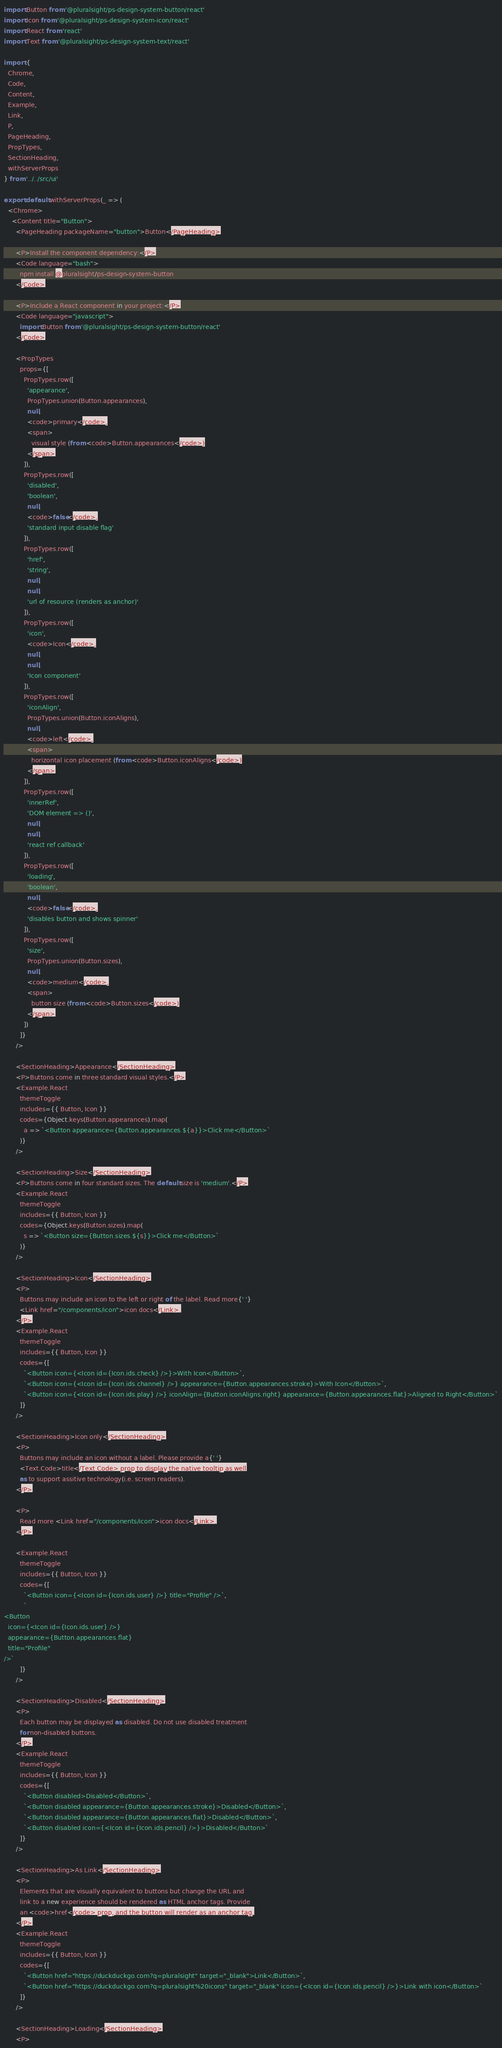<code> <loc_0><loc_0><loc_500><loc_500><_JavaScript_>import Button from '@pluralsight/ps-design-system-button/react'
import Icon from '@pluralsight/ps-design-system-icon/react'
import React from 'react'
import Text from '@pluralsight/ps-design-system-text/react'

import {
  Chrome,
  Code,
  Content,
  Example,
  Link,
  P,
  PageHeading,
  PropTypes,
  SectionHeading,
  withServerProps
} from '../../src/ui'

export default withServerProps(_ => (
  <Chrome>
    <Content title="Button">
      <PageHeading packageName="button">Button</PageHeading>

      <P>Install the component dependency:</P>
      <Code language="bash">
        npm install @pluralsight/ps-design-system-button
      </Code>

      <P>Include a React component in your project:</P>
      <Code language="javascript">
        import Button from '@pluralsight/ps-design-system-button/react'
      </Code>

      <PropTypes
        props={[
          PropTypes.row([
            'appearance',
            PropTypes.union(Button.appearances),
            null,
            <code>primary</code>,
            <span>
              visual style (from <code>Button.appearances</code>)
            </span>
          ]),
          PropTypes.row([
            'disabled',
            'boolean',
            null,
            <code>false</code>,
            'standard input disable flag'
          ]),
          PropTypes.row([
            'href',
            'string',
            null,
            null,
            'url of resource (renders as anchor)'
          ]),
          PropTypes.row([
            'icon',
            <code>Icon</code>,
            null,
            null,
            'Icon component'
          ]),
          PropTypes.row([
            'iconAlign',
            PropTypes.union(Button.iconAligns),
            null,
            <code>left</code>,
            <span>
              horizontal icon placement (from <code>Button.iconAligns</code>)
            </span>
          ]),
          PropTypes.row([
            'innerRef',
            'DOM element => ()',
            null,
            null,
            'react ref callback'
          ]),
          PropTypes.row([
            'loading',
            'boolean',
            null,
            <code>false</code>,
            'disables button and shows spinner'
          ]),
          PropTypes.row([
            'size',
            PropTypes.union(Button.sizes),
            null,
            <code>medium</code>,
            <span>
              button size (from <code>Button.sizes</code>)
            </span>
          ])
        ]}
      />

      <SectionHeading>Appearance</SectionHeading>
      <P>Buttons come in three standard visual styles.</P>
      <Example.React
        themeToggle
        includes={{ Button, Icon }}
        codes={Object.keys(Button.appearances).map(
          a => `<Button appearance={Button.appearances.${a}}>Click me</Button>`
        )}
      />

      <SectionHeading>Size</SectionHeading>
      <P>Buttons come in four standard sizes. The default size is 'medium'.</P>
      <Example.React
        themeToggle
        includes={{ Button, Icon }}
        codes={Object.keys(Button.sizes).map(
          s => `<Button size={Button.sizes.${s}}>Click me</Button>`
        )}
      />

      <SectionHeading>Icon</SectionHeading>
      <P>
        Buttons may include an icon to the left or right of the label. Read more{' '}
        <Link href="/components/icon">icon docs</Link>.
      </P>
      <Example.React
        themeToggle
        includes={{ Button, Icon }}
        codes={[
          `<Button icon={<Icon id={Icon.ids.check} />}>With Icon</Button>`,
          `<Button icon={<Icon id={Icon.ids.channel} />} appearance={Button.appearances.stroke}>With Icon</Button>`,
          `<Button icon={<Icon id={Icon.ids.play} />} iconAlign={Button.iconAligns.right} appearance={Button.appearances.flat}>Aligned to Right</Button>`
        ]}
      />

      <SectionHeading>Icon only</SectionHeading>
      <P>
        Buttons may include an icon without a label. Please provide a{' '}
        <Text.Code>title</Text.Code> prop to display the native tooltip as well
        as to support assitive technology(i.e. screen readers).
      </P>

      <P>
        Read more <Link href="/components/icon">icon docs</Link>.
      </P>

      <Example.React
        themeToggle
        includes={{ Button, Icon }}
        codes={[
          `<Button icon={<Icon id={Icon.ids.user} />} title="Profile" />`,
          `
<Button
  icon={<Icon id={Icon.ids.user} />}
  appearance={Button.appearances.flat}
  title="Profile"
/>`
        ]}
      />

      <SectionHeading>Disabled</SectionHeading>
      <P>
        Each button may be displayed as disabled. Do not use disabled treatment
        for non-disabled buttons.
      </P>
      <Example.React
        themeToggle
        includes={{ Button, Icon }}
        codes={[
          `<Button disabled>Disabled</Button>`,
          `<Button disabled appearance={Button.appearances.stroke}>Disabled</Button>`,
          `<Button disabled appearance={Button.appearances.flat}>Disabled</Button>`,
          `<Button disabled icon={<Icon id={Icon.ids.pencil} />}>Disabled</Button>`
        ]}
      />

      <SectionHeading>As Link</SectionHeading>
      <P>
        Elements that are visually equivalent to buttons but change the URL and
        link to a new experience should be rendered as HTML anchor tags. Provide
        an <code>href</code> prop, and the button will render as an anchor tag.
      </P>
      <Example.React
        themeToggle
        includes={{ Button, Icon }}
        codes={[
          `<Button href="https://duckduckgo.com?q=pluralsight" target="_blank">Link</Button>`,
          `<Button href="https://duckduckgo.com?q=pluralsight%20icons" target="_blank" icon={<Icon id={Icon.ids.pencil} />}>Link with icon</Button>`
        ]}
      />

      <SectionHeading>Loading</SectionHeading>
      <P></code> 